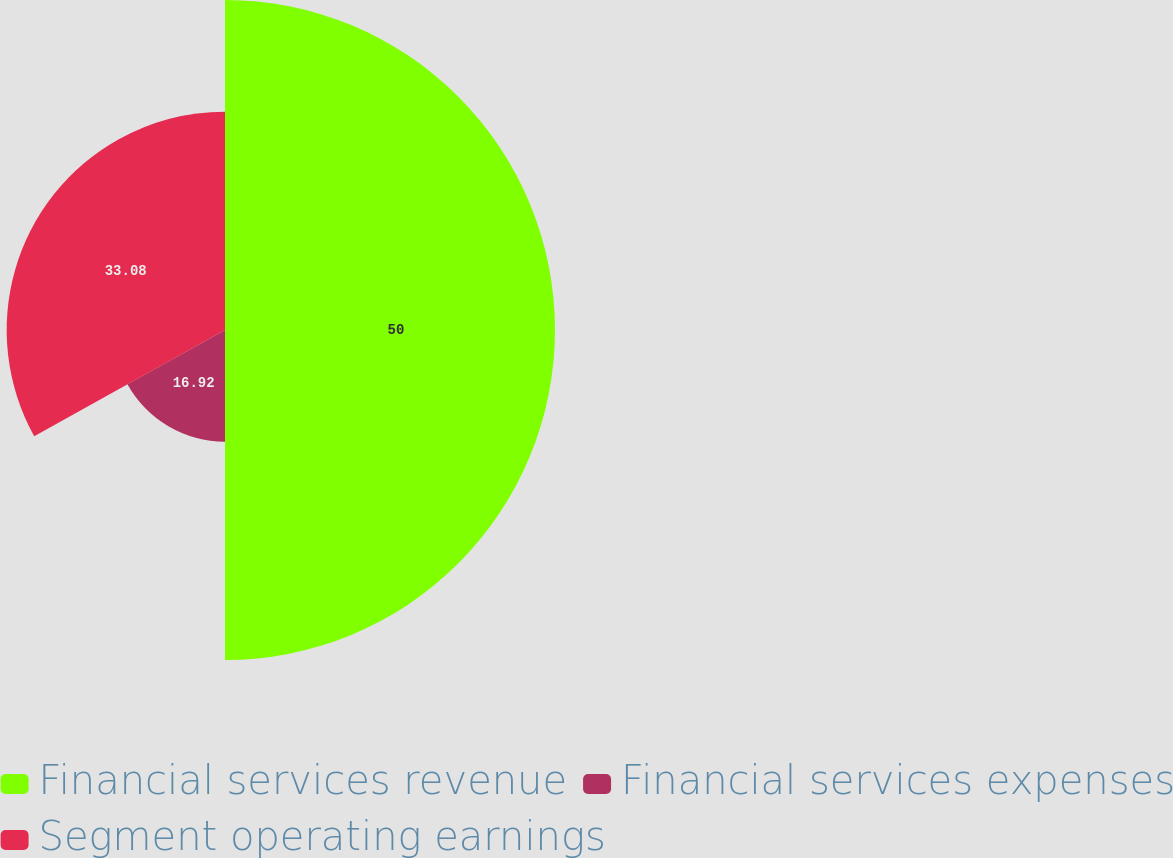<chart> <loc_0><loc_0><loc_500><loc_500><pie_chart><fcel>Financial services revenue<fcel>Financial services expenses<fcel>Segment operating earnings<nl><fcel>50.0%<fcel>16.92%<fcel>33.08%<nl></chart> 